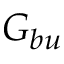Convert formula to latex. <formula><loc_0><loc_0><loc_500><loc_500>G _ { b u }</formula> 